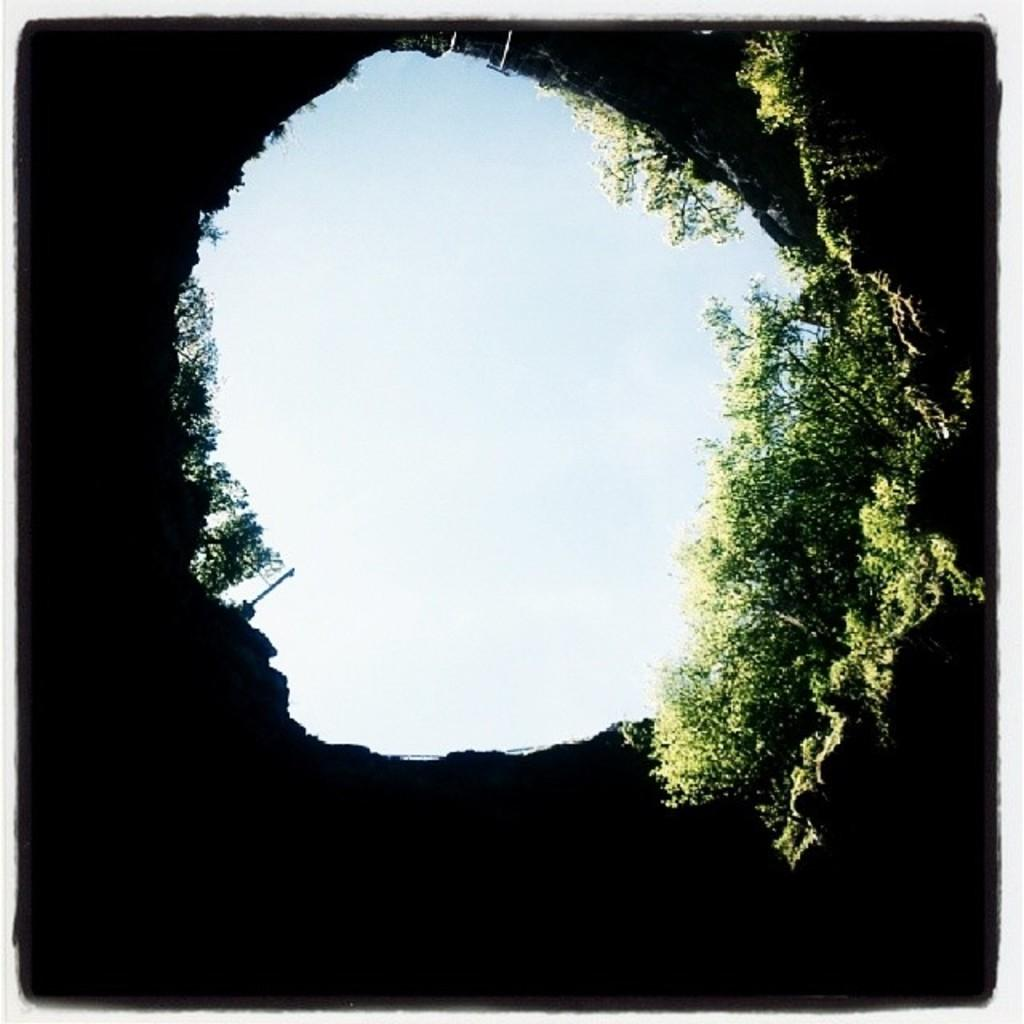What is the primary subject of the image? There are many plants in the image. What can be seen in the background of the image? The sky is visible in the image. How many legs can be seen on the plants in the image? Plants do not have legs, so this question cannot be answered based on the image. 